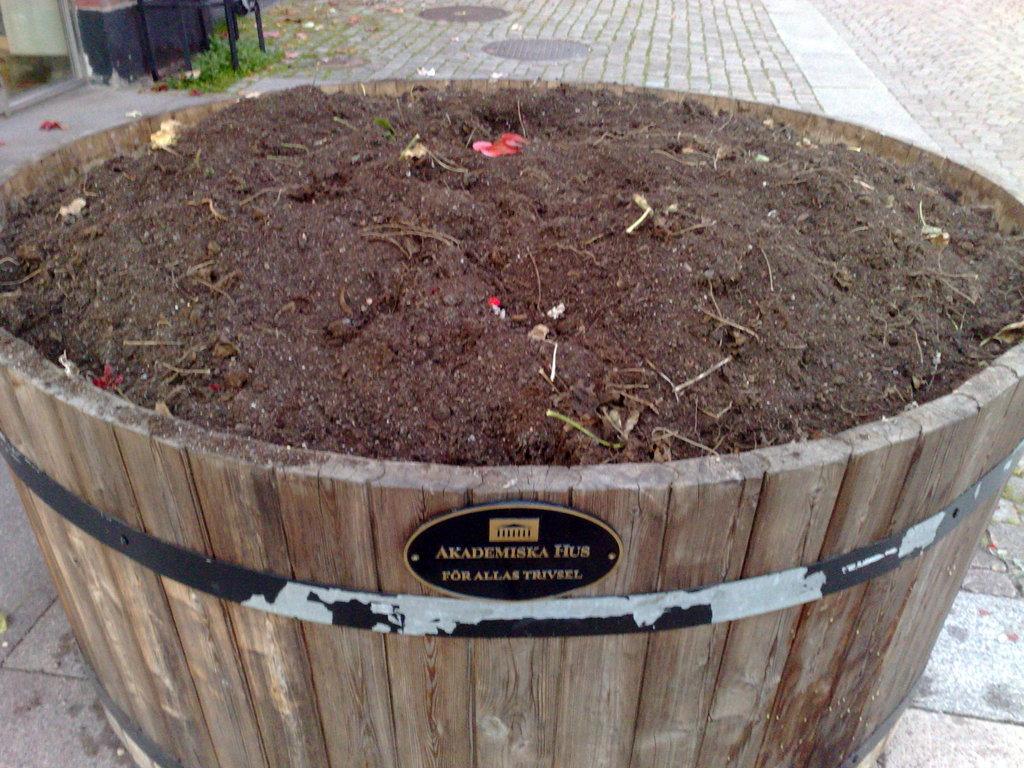Please provide a concise description of this image. In this picture i can see the clay in the wooden barrel. At the bottom there is a stamp which is attached on this. In the top left there is a bench near to the wall and door. Beside that i can see the grass. 